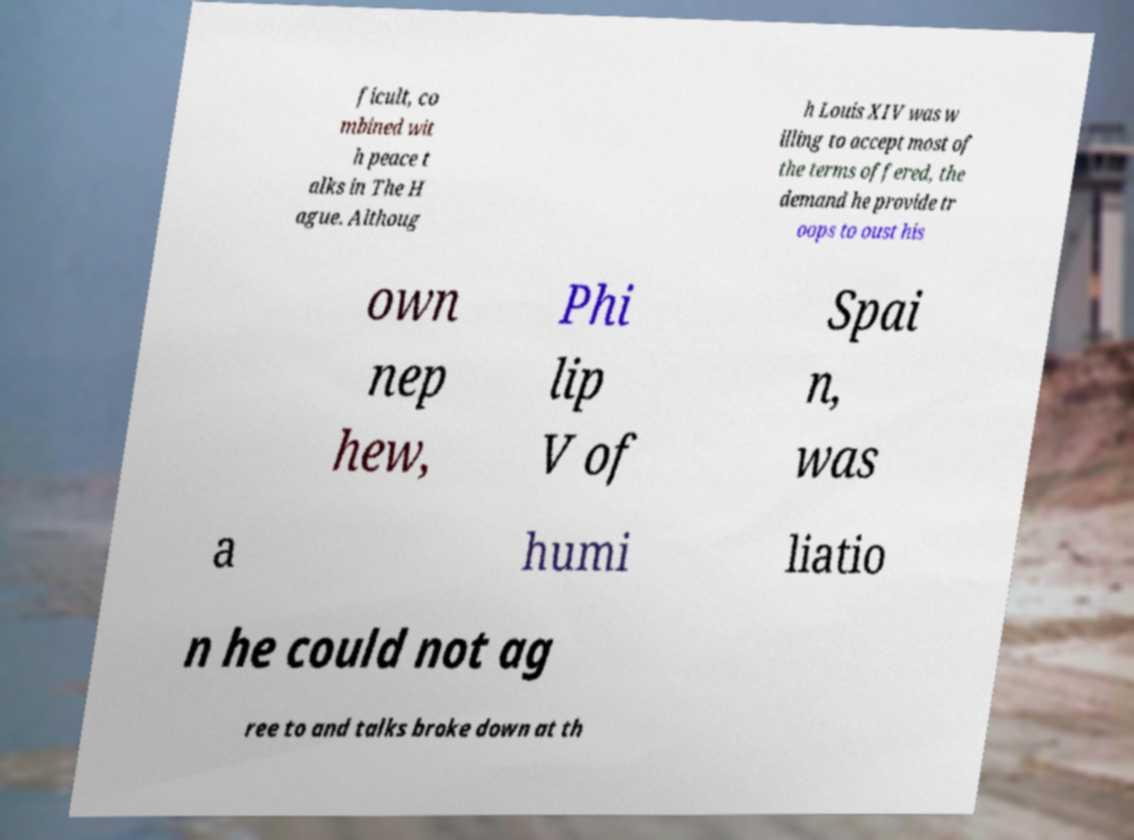For documentation purposes, I need the text within this image transcribed. Could you provide that? ficult, co mbined wit h peace t alks in The H ague. Althoug h Louis XIV was w illing to accept most of the terms offered, the demand he provide tr oops to oust his own nep hew, Phi lip V of Spai n, was a humi liatio n he could not ag ree to and talks broke down at th 